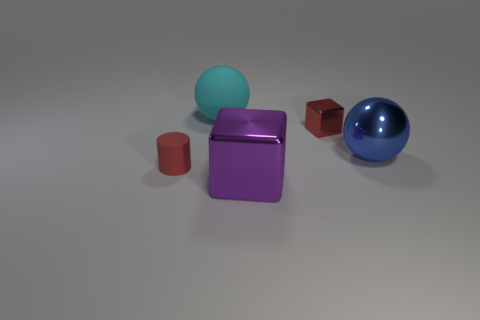What materials do the objects seem to be made of? The objects in the image appear to be made from different materials. The teal sphere and small brown cylinder have a matte finish, suggesting a plastic or non-metallic substance. The purple cube seems to have a metallic sheen, indicative of metal or a highly reflective material. The small crimson cube also appears matte, similar to the brown cylinder. Lastly, the blue sphere has a highly reflective metallic finish, akin to polished metal. 